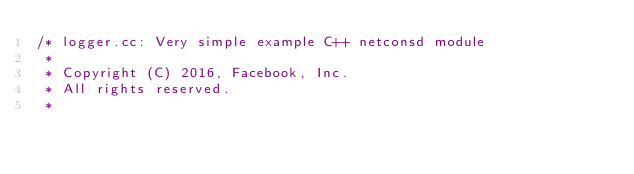Convert code to text. <code><loc_0><loc_0><loc_500><loc_500><_C++_>/* logger.cc: Very simple example C++ netconsd module
 *
 * Copyright (C) 2016, Facebook, Inc.
 * All rights reserved.
 *</code> 